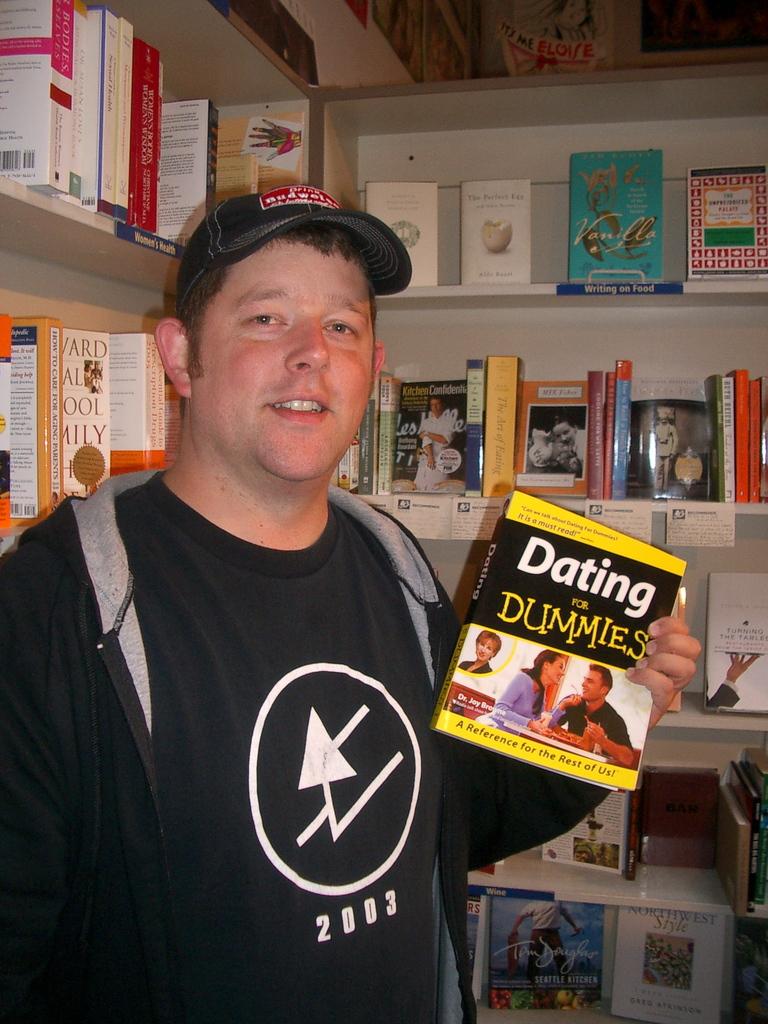What is the year on this man's shirt?
Your response must be concise. 2003. 